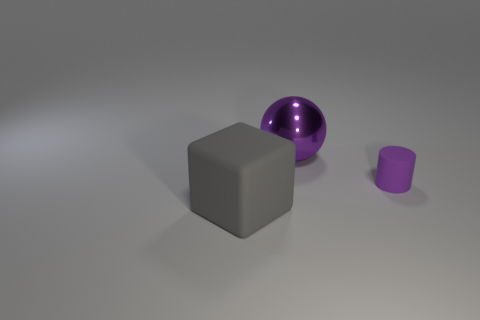Add 2 cylinders. How many objects exist? 5 Subtract all blocks. How many objects are left? 2 Add 3 purple things. How many purple things exist? 5 Subtract 0 yellow cylinders. How many objects are left? 3 Subtract all blue matte spheres. Subtract all large purple metal balls. How many objects are left? 2 Add 1 big cubes. How many big cubes are left? 2 